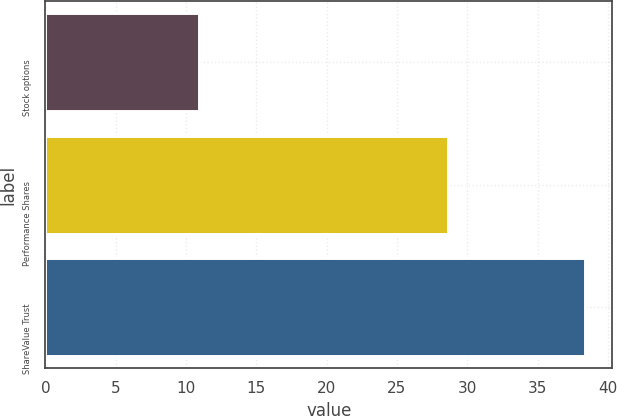<chart> <loc_0><loc_0><loc_500><loc_500><bar_chart><fcel>Stock options<fcel>Performance Shares<fcel>ShareValue Trust<nl><fcel>10.9<fcel>28.6<fcel>38.4<nl></chart> 